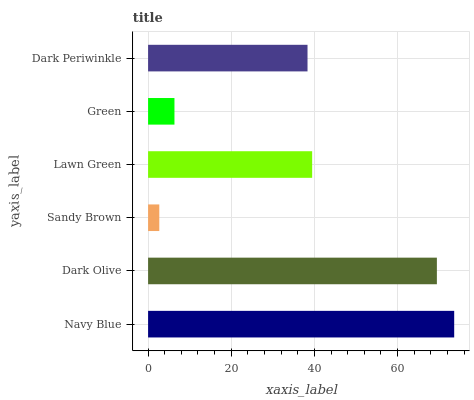Is Sandy Brown the minimum?
Answer yes or no. Yes. Is Navy Blue the maximum?
Answer yes or no. Yes. Is Dark Olive the minimum?
Answer yes or no. No. Is Dark Olive the maximum?
Answer yes or no. No. Is Navy Blue greater than Dark Olive?
Answer yes or no. Yes. Is Dark Olive less than Navy Blue?
Answer yes or no. Yes. Is Dark Olive greater than Navy Blue?
Answer yes or no. No. Is Navy Blue less than Dark Olive?
Answer yes or no. No. Is Lawn Green the high median?
Answer yes or no. Yes. Is Dark Periwinkle the low median?
Answer yes or no. Yes. Is Green the high median?
Answer yes or no. No. Is Dark Olive the low median?
Answer yes or no. No. 